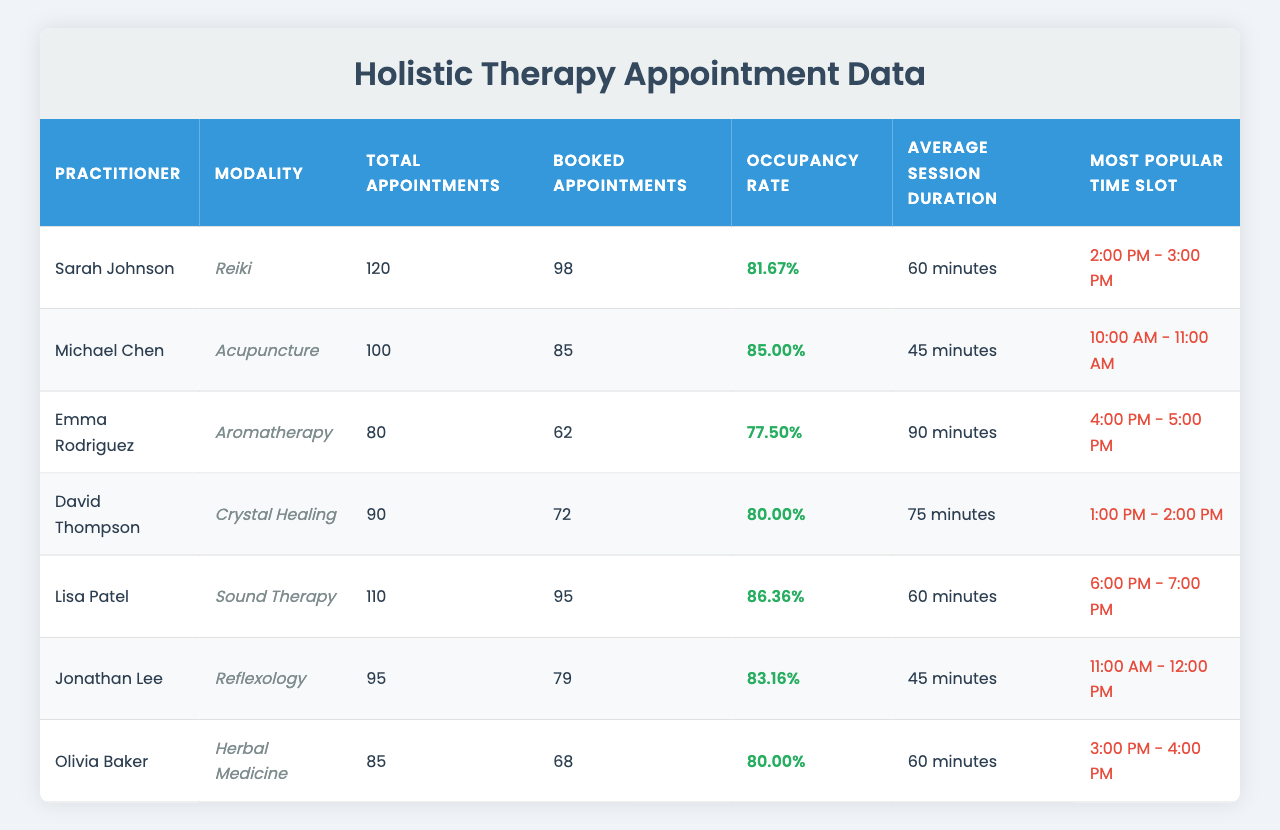What is the total number of appointments for Sarah Johnson? The table lists "Total Appointments" for Sarah Johnson as 120.
Answer: 120 What is the occupancy rate for Lisa Patel's Sound Therapy? The occupancy rate for Lisa Patel's Sound Therapy is noted as 86.36%.
Answer: 86.36% Which practitioner has the highest number of booked appointments? By comparing the "Booked Appointments" column, Sarah Johnson has 98, which is the highest value.
Answer: Sarah Johnson What is the average session duration for David Thompson? The table states the "Average Session Duration" for David Thompson is 75 minutes.
Answer: 75 minutes Is Emma Rodriguez's Aromatherapy modality more popular than average, based on her occupancy rate? Emma Rodriguez has an occupancy rate of 77.50%, which is below the average of the practicing modalities in the table, making it less popular.
Answer: No What would be the total number of booked appointments for all practitioners combined? Adding up the "Booked Appointments" values: 98 + 85 + 62 + 72 + 95 + 79 + 68 = 559.
Answer: 559 Which modality has the lowest total appointments? By examining the "Total Appointments", Aromatherapy has the lowest with 80.
Answer: Aromatherapy Between Jonathan Lee and David Thompson, who has a better occupancy rate? Jonathan Lee has an occupancy rate of 83.16% while David Thompson has 80.00%, so Jonathan Lee has a better occupancy rate.
Answer: Jonathan Lee What is the difference in total appointments between Sarah Johnson and Michael Chen? Sarah Johnson has 120 appointments and Michael Chen has 100. The difference is 120 - 100 = 20.
Answer: 20 Which time slot is the most popular for Reiki sessions? The table indicates that the most popular time slot for Reiki sessions is from 2:00 PM to 3:00 PM.
Answer: 2:00 PM - 3:00 PM 